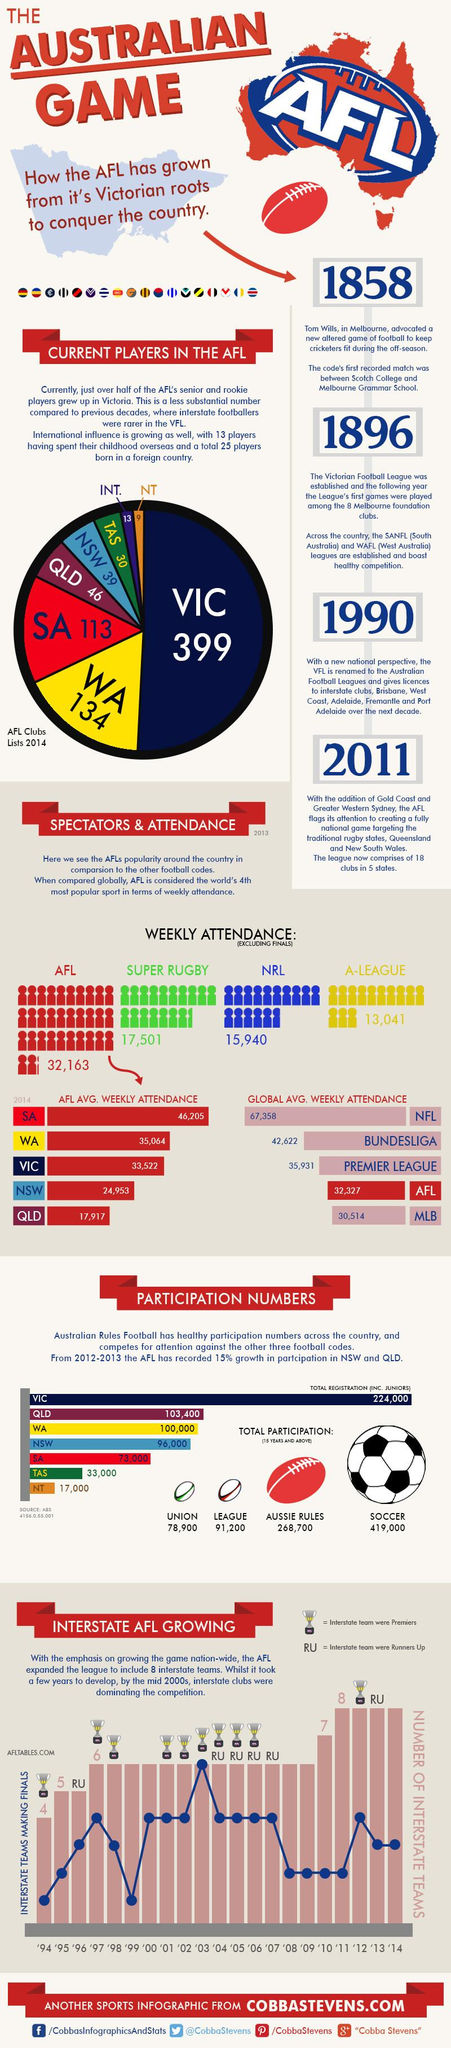Give some essential details in this illustration. The average weekly attendance in SA is 21,252, while in NSW it is 21,252 in AFL games. The difference in global average weekly attendance between the National Football League (NFL) and the Arena Football League (AFL) is 35,031. The difference in participation numbers between West Australia and New South Wales is approximately 4,000. The second largest number of AFL players hails from Western Australia. The year with the lowest recorded participation by the interstate clubs was 1999. 